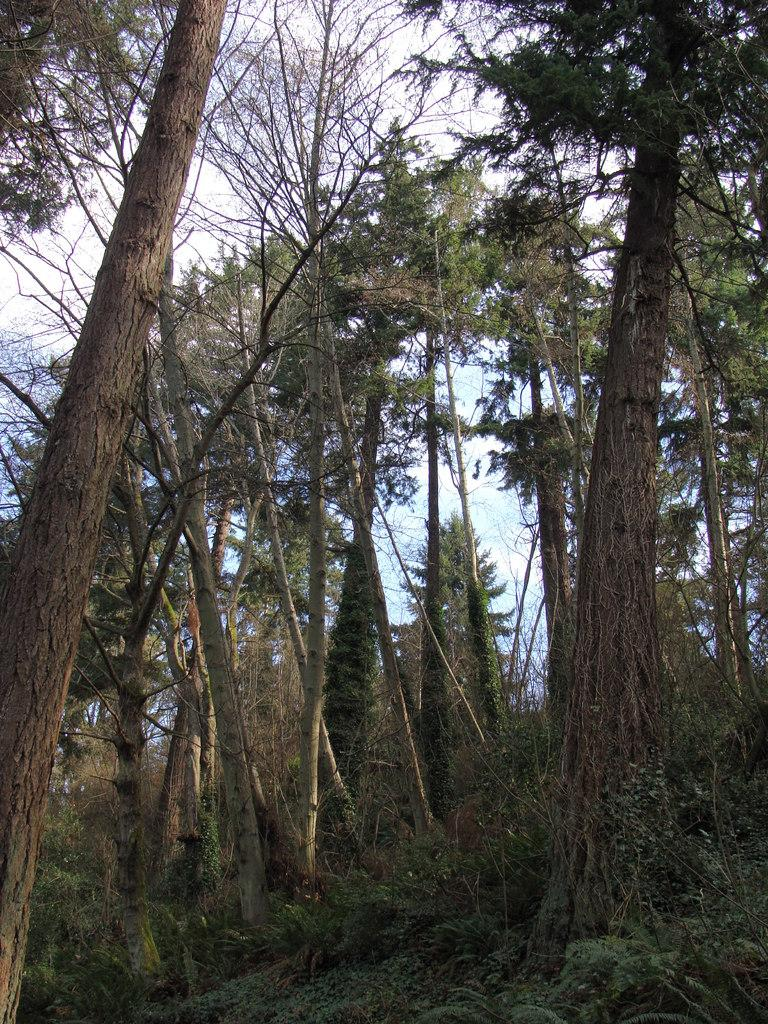What type of vegetation can be seen in the image? There are trees and plants on the ground in the image. What can be seen in the background of the image? The sky is visible in the background of the image. What type of legal advice is the tiger providing in the image? There is no tiger or legal advice present in the image; it features trees and plants with a visible sky in the background. 